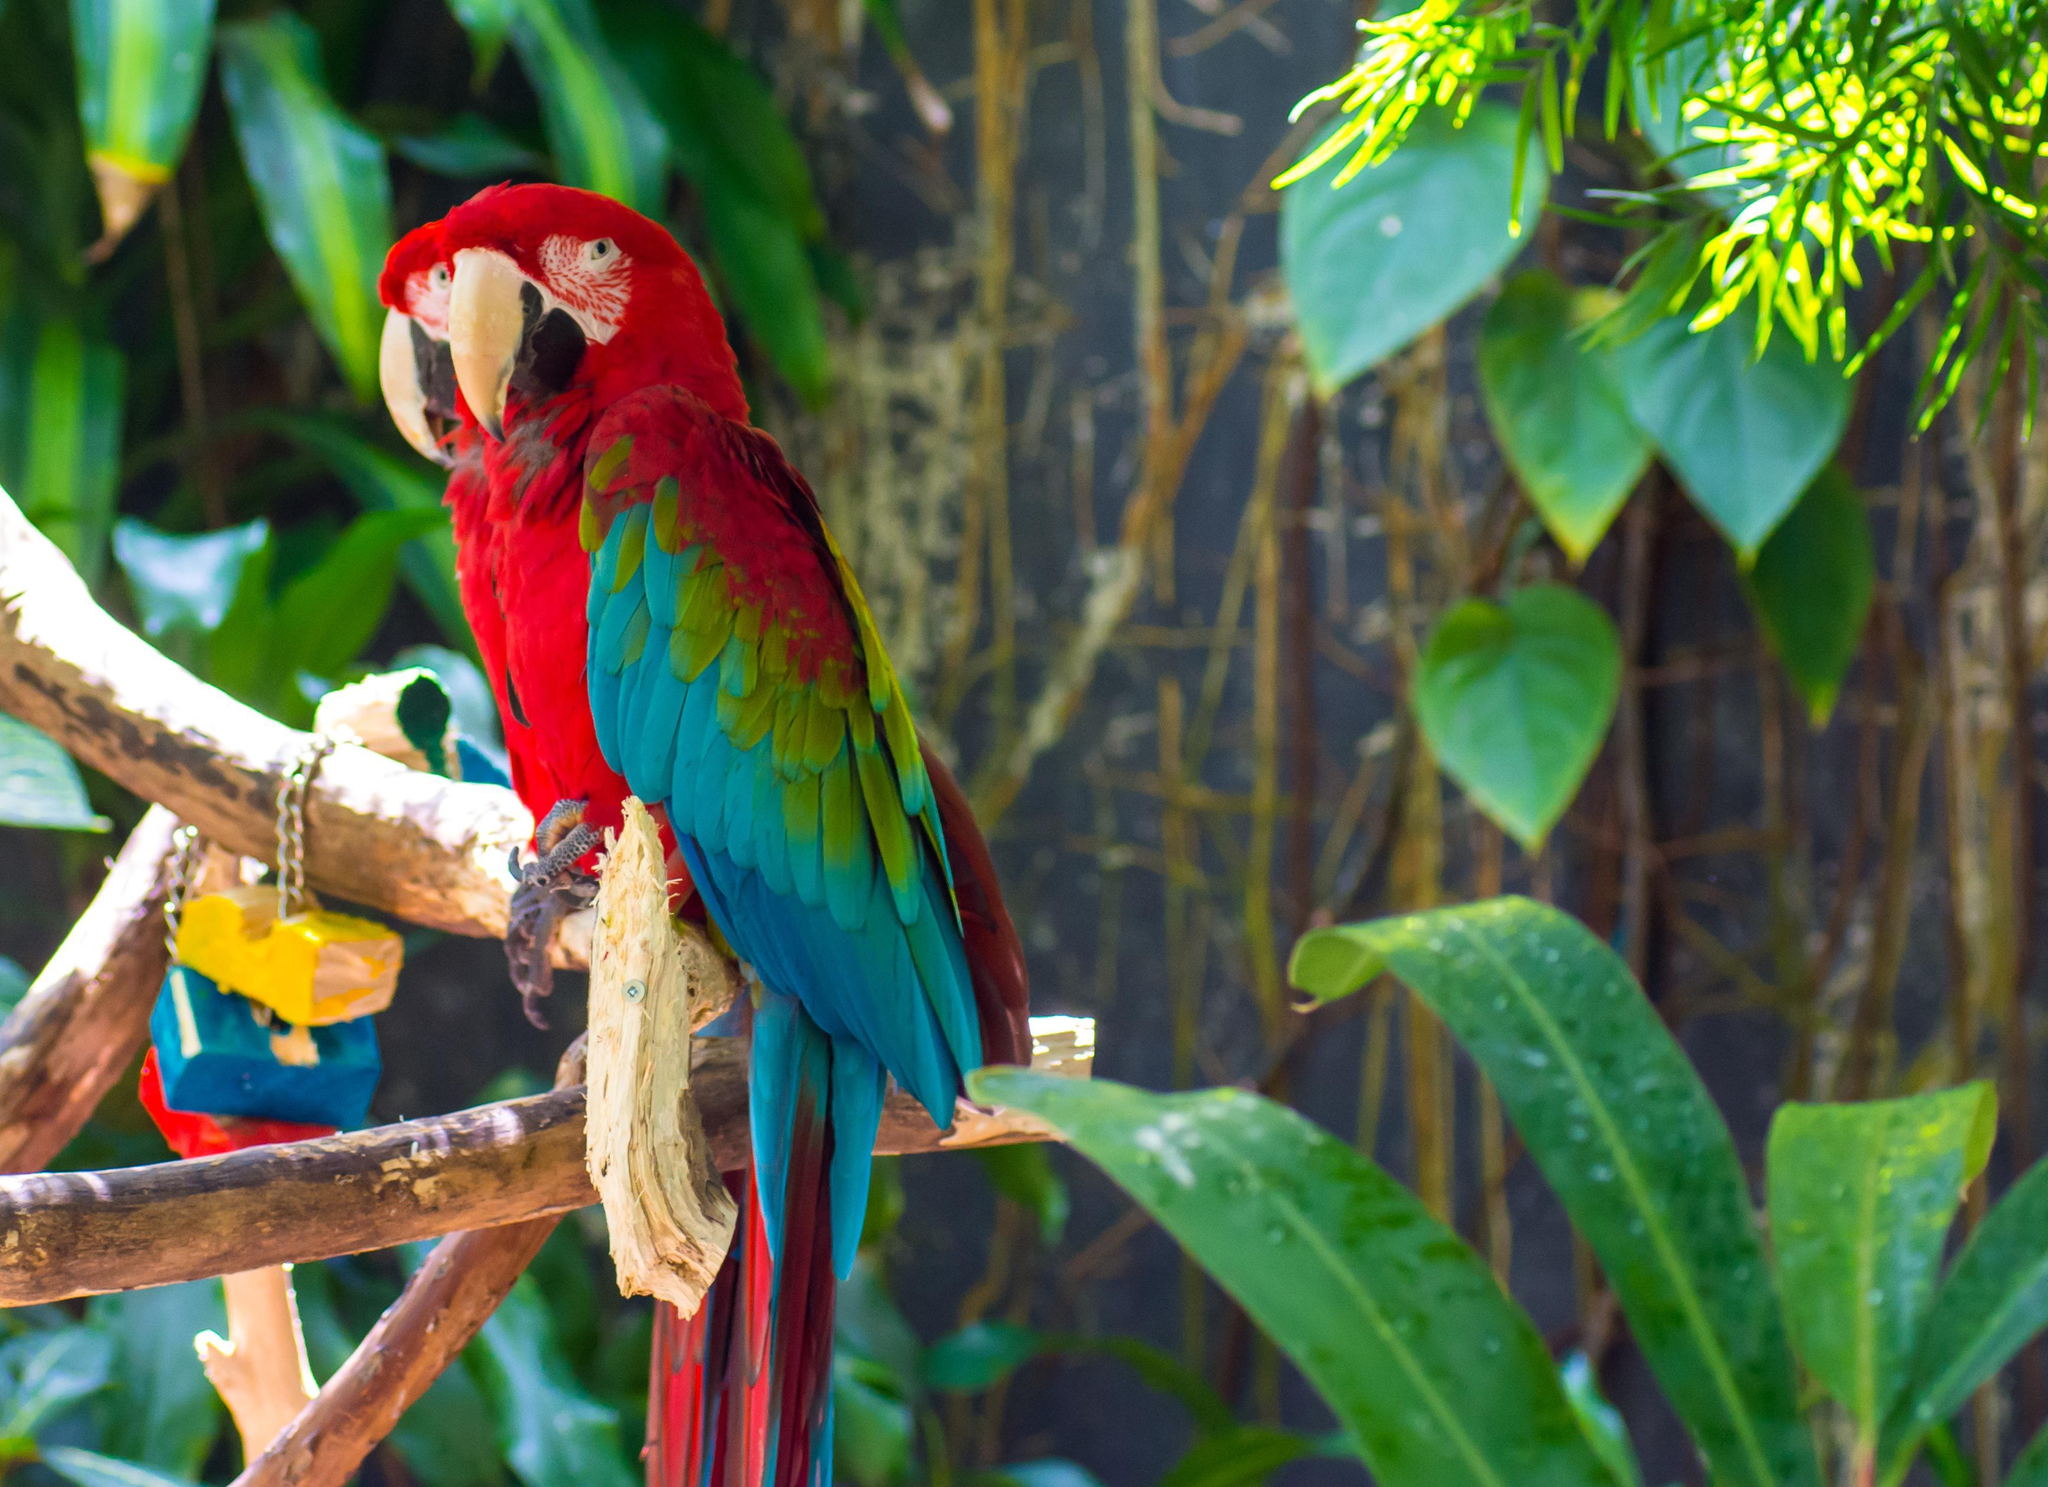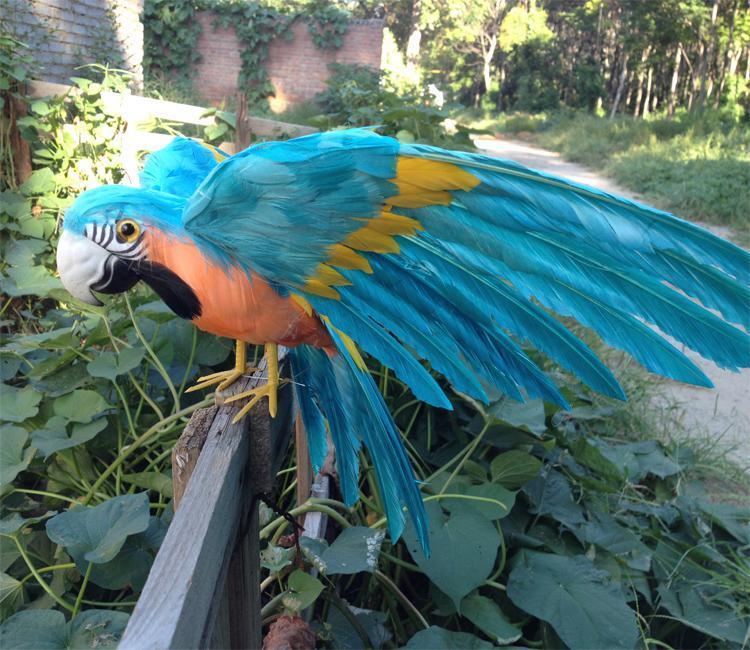The first image is the image on the left, the second image is the image on the right. For the images shown, is this caption "An image contains various parrots perched on a humans arms and shoulders." true? Answer yes or no. No. The first image is the image on the left, the second image is the image on the right. Given the left and right images, does the statement "The combined images show two people with parrots perched on various parts of their bodies." hold true? Answer yes or no. No. 